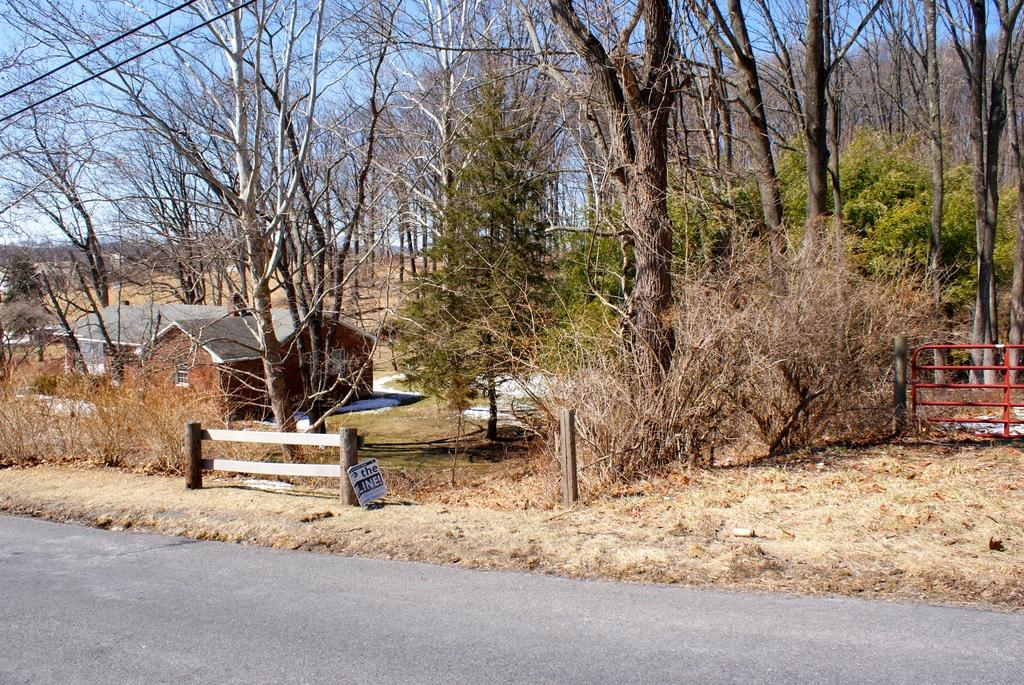What type of structures can be seen in the image? There are houses in the image. What is present alongside the houses? There is fencing in the image. What other natural elements can be seen in the image? There are trees in the image. What color is the sky in the background of the image? The sky is blue in the background of the image. Where is the nest located in the image? There is no nest present in the image. Can you describe the sofa in the image? There is no sofa present in the image. 